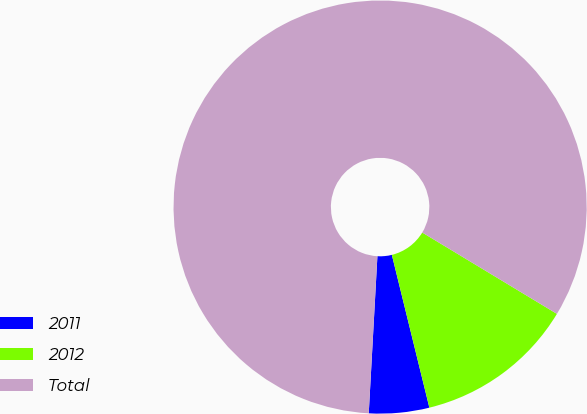Convert chart to OTSL. <chart><loc_0><loc_0><loc_500><loc_500><pie_chart><fcel>2011<fcel>2012<fcel>Total<nl><fcel>4.71%<fcel>12.52%<fcel>82.78%<nl></chart> 